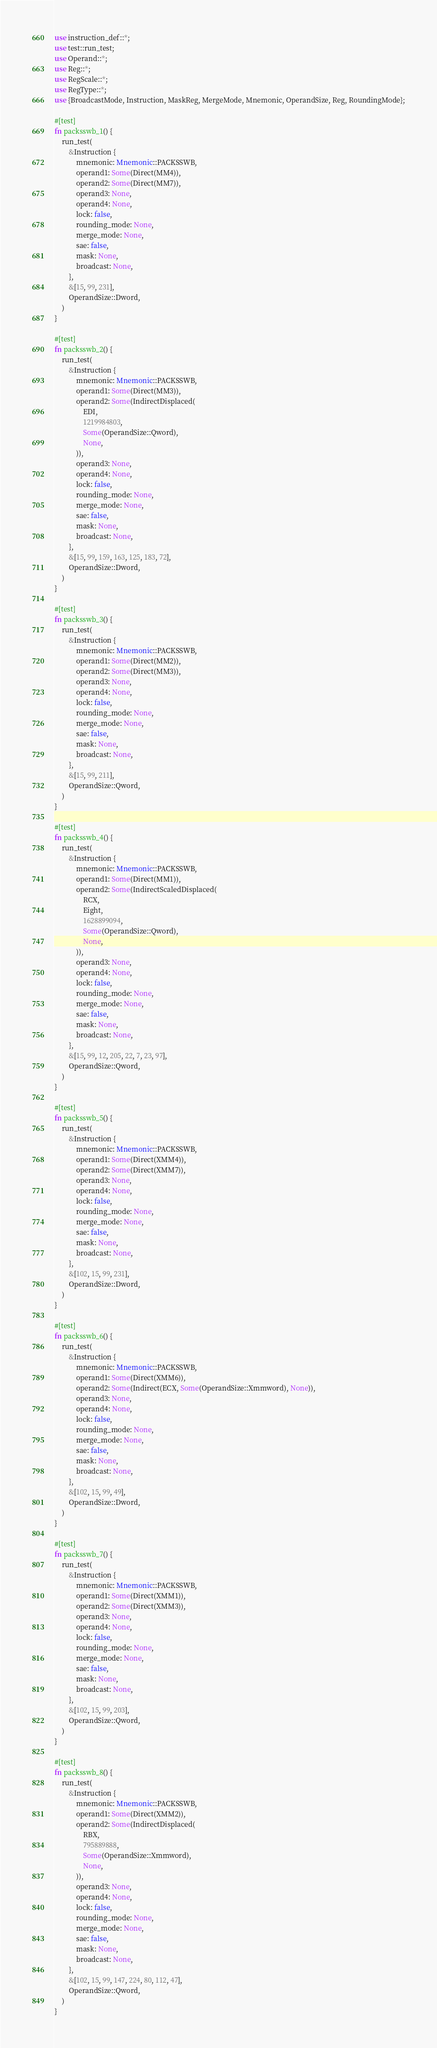Convert code to text. <code><loc_0><loc_0><loc_500><loc_500><_Rust_>use instruction_def::*;
use test::run_test;
use Operand::*;
use Reg::*;
use RegScale::*;
use RegType::*;
use {BroadcastMode, Instruction, MaskReg, MergeMode, Mnemonic, OperandSize, Reg, RoundingMode};

#[test]
fn packsswb_1() {
    run_test(
        &Instruction {
            mnemonic: Mnemonic::PACKSSWB,
            operand1: Some(Direct(MM4)),
            operand2: Some(Direct(MM7)),
            operand3: None,
            operand4: None,
            lock: false,
            rounding_mode: None,
            merge_mode: None,
            sae: false,
            mask: None,
            broadcast: None,
        },
        &[15, 99, 231],
        OperandSize::Dword,
    )
}

#[test]
fn packsswb_2() {
    run_test(
        &Instruction {
            mnemonic: Mnemonic::PACKSSWB,
            operand1: Some(Direct(MM3)),
            operand2: Some(IndirectDisplaced(
                EDI,
                1219984803,
                Some(OperandSize::Qword),
                None,
            )),
            operand3: None,
            operand4: None,
            lock: false,
            rounding_mode: None,
            merge_mode: None,
            sae: false,
            mask: None,
            broadcast: None,
        },
        &[15, 99, 159, 163, 125, 183, 72],
        OperandSize::Dword,
    )
}

#[test]
fn packsswb_3() {
    run_test(
        &Instruction {
            mnemonic: Mnemonic::PACKSSWB,
            operand1: Some(Direct(MM2)),
            operand2: Some(Direct(MM3)),
            operand3: None,
            operand4: None,
            lock: false,
            rounding_mode: None,
            merge_mode: None,
            sae: false,
            mask: None,
            broadcast: None,
        },
        &[15, 99, 211],
        OperandSize::Qword,
    )
}

#[test]
fn packsswb_4() {
    run_test(
        &Instruction {
            mnemonic: Mnemonic::PACKSSWB,
            operand1: Some(Direct(MM1)),
            operand2: Some(IndirectScaledDisplaced(
                RCX,
                Eight,
                1628899094,
                Some(OperandSize::Qword),
                None,
            )),
            operand3: None,
            operand4: None,
            lock: false,
            rounding_mode: None,
            merge_mode: None,
            sae: false,
            mask: None,
            broadcast: None,
        },
        &[15, 99, 12, 205, 22, 7, 23, 97],
        OperandSize::Qword,
    )
}

#[test]
fn packsswb_5() {
    run_test(
        &Instruction {
            mnemonic: Mnemonic::PACKSSWB,
            operand1: Some(Direct(XMM4)),
            operand2: Some(Direct(XMM7)),
            operand3: None,
            operand4: None,
            lock: false,
            rounding_mode: None,
            merge_mode: None,
            sae: false,
            mask: None,
            broadcast: None,
        },
        &[102, 15, 99, 231],
        OperandSize::Dword,
    )
}

#[test]
fn packsswb_6() {
    run_test(
        &Instruction {
            mnemonic: Mnemonic::PACKSSWB,
            operand1: Some(Direct(XMM6)),
            operand2: Some(Indirect(ECX, Some(OperandSize::Xmmword), None)),
            operand3: None,
            operand4: None,
            lock: false,
            rounding_mode: None,
            merge_mode: None,
            sae: false,
            mask: None,
            broadcast: None,
        },
        &[102, 15, 99, 49],
        OperandSize::Dword,
    )
}

#[test]
fn packsswb_7() {
    run_test(
        &Instruction {
            mnemonic: Mnemonic::PACKSSWB,
            operand1: Some(Direct(XMM1)),
            operand2: Some(Direct(XMM3)),
            operand3: None,
            operand4: None,
            lock: false,
            rounding_mode: None,
            merge_mode: None,
            sae: false,
            mask: None,
            broadcast: None,
        },
        &[102, 15, 99, 203],
        OperandSize::Qword,
    )
}

#[test]
fn packsswb_8() {
    run_test(
        &Instruction {
            mnemonic: Mnemonic::PACKSSWB,
            operand1: Some(Direct(XMM2)),
            operand2: Some(IndirectDisplaced(
                RBX,
                795889888,
                Some(OperandSize::Xmmword),
                None,
            )),
            operand3: None,
            operand4: None,
            lock: false,
            rounding_mode: None,
            merge_mode: None,
            sae: false,
            mask: None,
            broadcast: None,
        },
        &[102, 15, 99, 147, 224, 80, 112, 47],
        OperandSize::Qword,
    )
}
</code> 